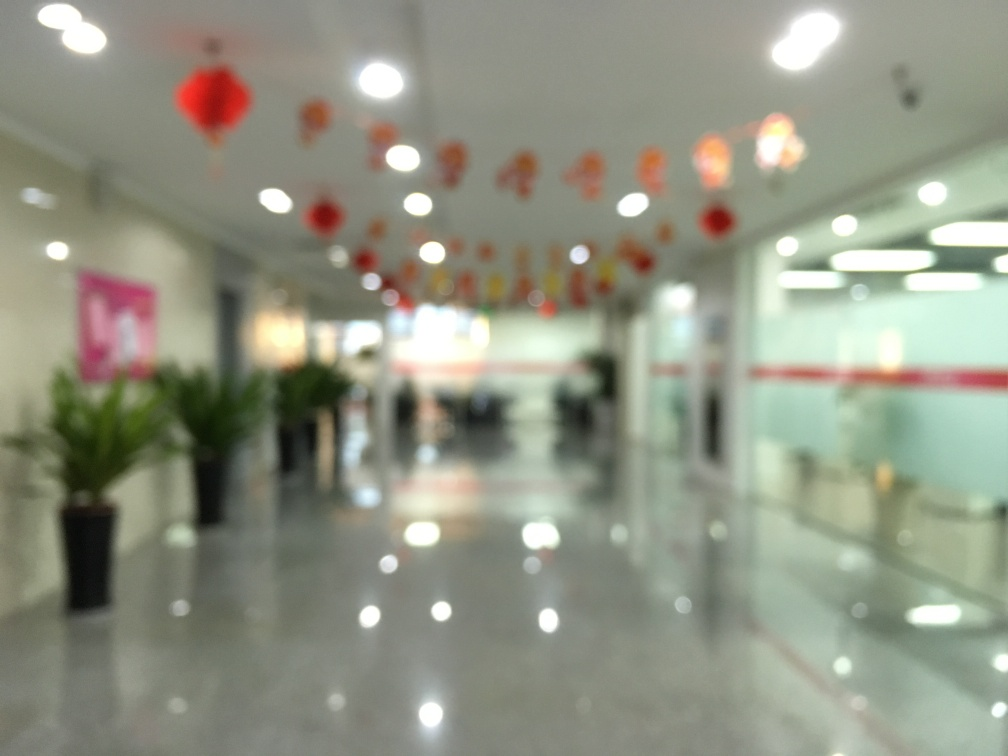Could you tell me what kind of event might be taking place here? Although the image is blurred, the red lantern decorations suggest that this space could be set up for a celebration related to Chinese cultural events, possibly a New Year or a festival. What could indicate that this is a professional or public space rather than a private one? The presence of neatly placed potted plants, a shiny tiled floor, and what seems to be a reception desk in the background with informational signs indicates that this is likely a professional or public space, such as an office building or a hotel lobby. 